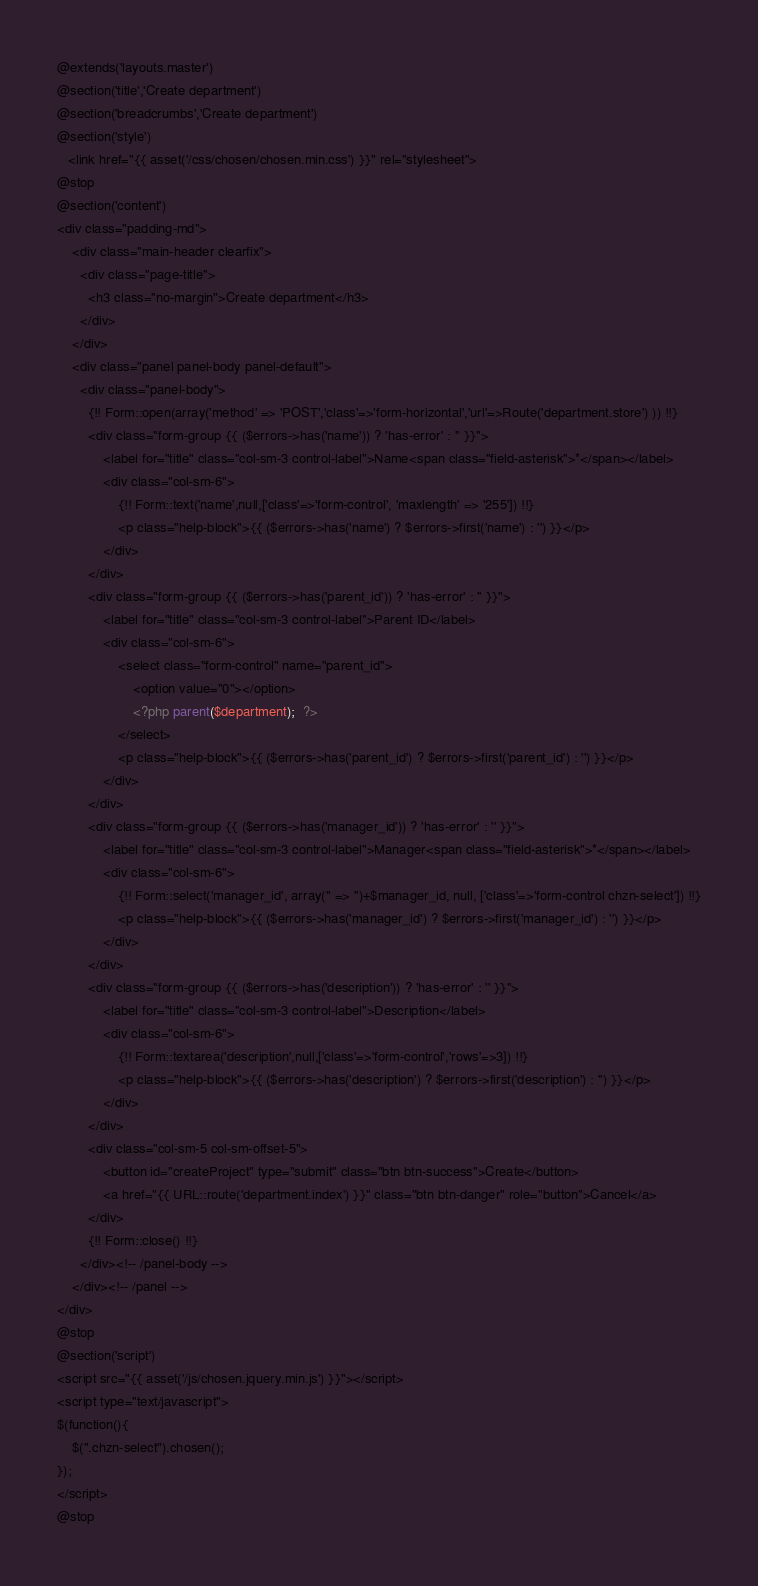<code> <loc_0><loc_0><loc_500><loc_500><_PHP_>@extends('layouts.master')
@section('title','Create department')
@section('breadcrumbs','Create department')
@section('style')
   <link href="{{ asset('/css/chosen/chosen.min.css') }}" rel="stylesheet">
@stop
@section('content')
<div class="padding-md">
    <div class="main-header clearfix">
      <div class="page-title">
        <h3 class="no-margin">Create department</h3>
      </div>
    </div>
    <div class="panel panel-body panel-default">
      <div class="panel-body">
        {!! Form::open(array('method' => 'POST','class'=>'form-horizontal','url'=>Route('department.store') )) !!}
        <div class="form-group {{ ($errors->has('name')) ? 'has-error' : '' }}">
            <label for="title" class="col-sm-3 control-label">Name<span class="field-asterisk">*</span></label>
            <div class="col-sm-6">
                {!! Form::text('name',null,['class'=>'form-control', 'maxlength' => '255']) !!}
                <p class="help-block">{{ ($errors->has('name') ? $errors->first('name') : '') }}</p>
            </div>
        </div>
        <div class="form-group {{ ($errors->has('parent_id')) ? 'has-error' : '' }}">
            <label for="title" class="col-sm-3 control-label">Parent ID</label>
            <div class="col-sm-6">
                <select class="form-control" name="parent_id">
                    <option value="0"></option>
                    <?php parent($department);  ?>
                </select>
                <p class="help-block">{{ ($errors->has('parent_id') ? $errors->first('parent_id') : '') }}</p>
            </div>
        </div>
        <div class="form-group {{ ($errors->has('manager_id')) ? 'has-error' : '' }}">
            <label for="title" class="col-sm-3 control-label">Manager<span class="field-asterisk">*</span></label>
            <div class="col-sm-6">
                {!! Form::select('manager_id', array('' => '')+$manager_id, null, ['class'=>'form-control chzn-select']) !!}
                <p class="help-block">{{ ($errors->has('manager_id') ? $errors->first('manager_id') : '') }}</p>
            </div>
        </div>
        <div class="form-group {{ ($errors->has('description')) ? 'has-error' : '' }}">
            <label for="title" class="col-sm-3 control-label">Description</label>
            <div class="col-sm-6">
                {!! Form::textarea('description',null,['class'=>'form-control','rows'=>3]) !!}
                <p class="help-block">{{ ($errors->has('description') ? $errors->first('description') : '') }}</p>
            </div>
        </div>
        <div class="col-sm-5 col-sm-offset-5">
            <button id="createProject" type="submit" class="btn btn-success">Create</button>
            <a href="{{ URL::route('department.index') }}" class="btn btn-danger" role="button">Cancel</a>
        </div>
        {!! Form::close() !!}
      </div><!-- /panel-body -->
    </div><!-- /panel -->
</div>
@stop
@section('script')
<script src="{{ asset('/js/chosen.jquery.min.js') }}"></script>
<script type="text/javascript">
$(function(){
    $(".chzn-select").chosen();
});
</script>
@stop</code> 